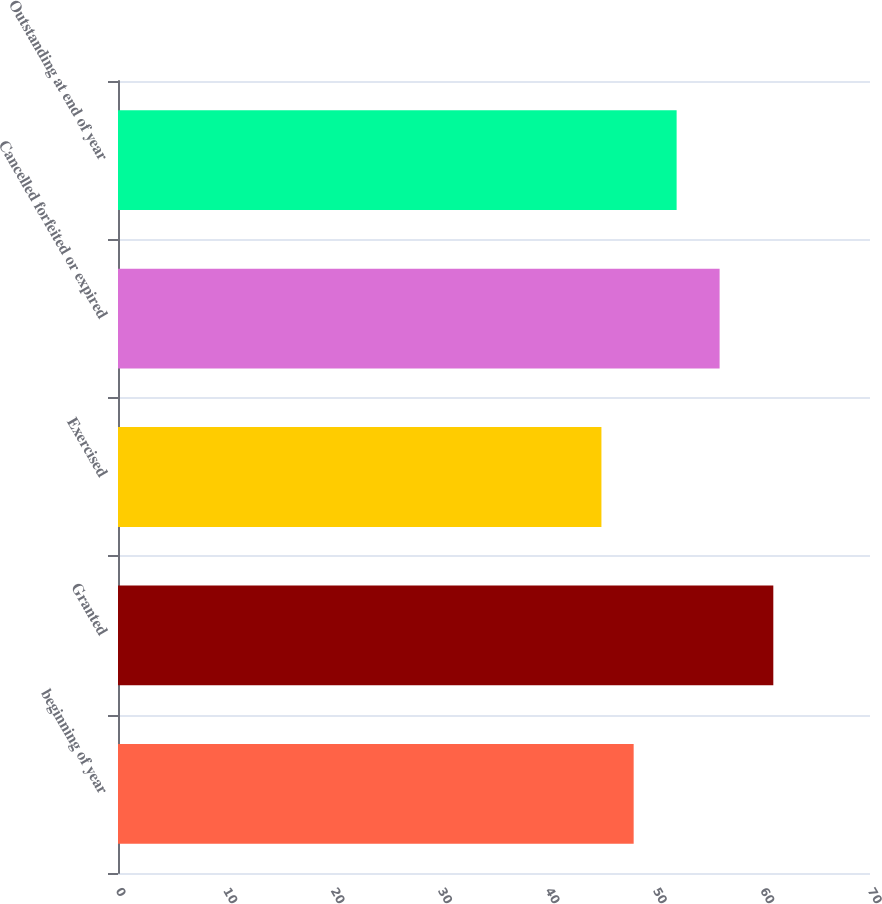<chart> <loc_0><loc_0><loc_500><loc_500><bar_chart><fcel>beginning of year<fcel>Granted<fcel>Exercised<fcel>Cancelled forfeited or expired<fcel>Outstanding at end of year<nl><fcel>48<fcel>61<fcel>45<fcel>56<fcel>52<nl></chart> 